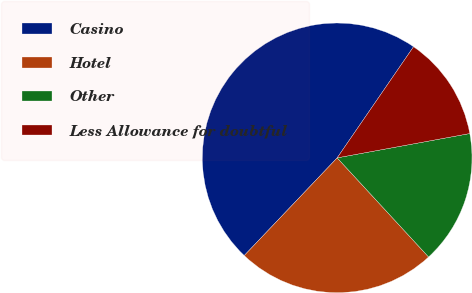<chart> <loc_0><loc_0><loc_500><loc_500><pie_chart><fcel>Casino<fcel>Hotel<fcel>Other<fcel>Less Allowance for doubtful<nl><fcel>47.48%<fcel>23.96%<fcel>16.03%<fcel>12.53%<nl></chart> 